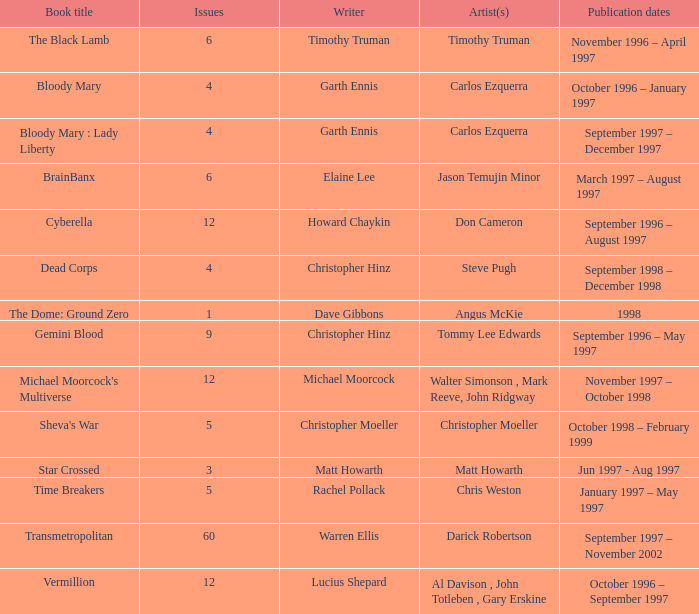What artist has a book called cyberella Don Cameron. 